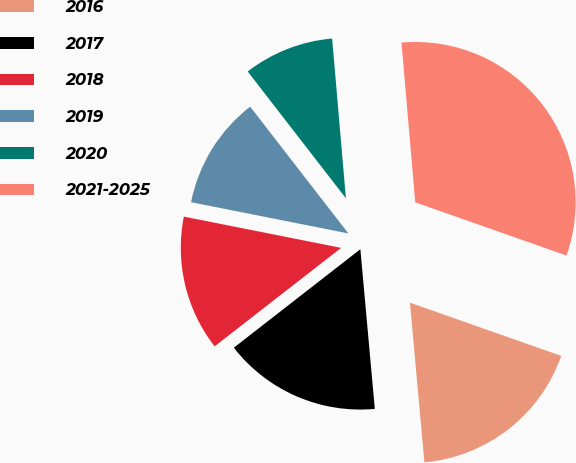Convert chart to OTSL. <chart><loc_0><loc_0><loc_500><loc_500><pie_chart><fcel>2016<fcel>2017<fcel>2018<fcel>2019<fcel>2020<fcel>2021-2025<nl><fcel>18.18%<fcel>15.91%<fcel>13.65%<fcel>11.39%<fcel>9.12%<fcel>31.75%<nl></chart> 